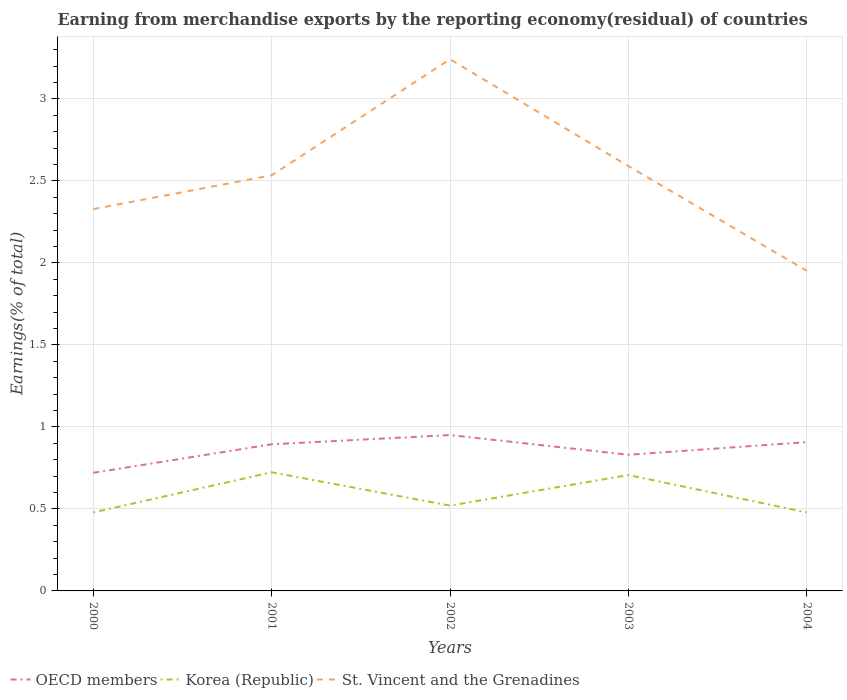How many different coloured lines are there?
Give a very brief answer. 3. Is the number of lines equal to the number of legend labels?
Give a very brief answer. Yes. Across all years, what is the maximum percentage of amount earned from merchandise exports in Korea (Republic)?
Your answer should be compact. 0.48. In which year was the percentage of amount earned from merchandise exports in OECD members maximum?
Your answer should be very brief. 2000. What is the total percentage of amount earned from merchandise exports in OECD members in the graph?
Provide a short and direct response. -0.19. What is the difference between the highest and the second highest percentage of amount earned from merchandise exports in OECD members?
Your answer should be compact. 0.23. Is the percentage of amount earned from merchandise exports in Korea (Republic) strictly greater than the percentage of amount earned from merchandise exports in St. Vincent and the Grenadines over the years?
Your answer should be compact. Yes. How many lines are there?
Provide a succinct answer. 3. Does the graph contain grids?
Provide a short and direct response. Yes. How many legend labels are there?
Ensure brevity in your answer.  3. How are the legend labels stacked?
Your response must be concise. Horizontal. What is the title of the graph?
Your answer should be compact. Earning from merchandise exports by the reporting economy(residual) of countries. What is the label or title of the Y-axis?
Make the answer very short. Earnings(% of total). What is the Earnings(% of total) in OECD members in 2000?
Your response must be concise. 0.72. What is the Earnings(% of total) of Korea (Republic) in 2000?
Your answer should be compact. 0.48. What is the Earnings(% of total) of St. Vincent and the Grenadines in 2000?
Provide a short and direct response. 2.33. What is the Earnings(% of total) in OECD members in 2001?
Offer a very short reply. 0.89. What is the Earnings(% of total) in Korea (Republic) in 2001?
Make the answer very short. 0.72. What is the Earnings(% of total) of St. Vincent and the Grenadines in 2001?
Offer a very short reply. 2.53. What is the Earnings(% of total) in OECD members in 2002?
Offer a terse response. 0.95. What is the Earnings(% of total) in Korea (Republic) in 2002?
Give a very brief answer. 0.52. What is the Earnings(% of total) in St. Vincent and the Grenadines in 2002?
Keep it short and to the point. 3.24. What is the Earnings(% of total) of OECD members in 2003?
Your answer should be compact. 0.83. What is the Earnings(% of total) of Korea (Republic) in 2003?
Give a very brief answer. 0.71. What is the Earnings(% of total) in St. Vincent and the Grenadines in 2003?
Keep it short and to the point. 2.59. What is the Earnings(% of total) of OECD members in 2004?
Provide a short and direct response. 0.91. What is the Earnings(% of total) in Korea (Republic) in 2004?
Your response must be concise. 0.48. What is the Earnings(% of total) of St. Vincent and the Grenadines in 2004?
Offer a very short reply. 1.95. Across all years, what is the maximum Earnings(% of total) of OECD members?
Provide a succinct answer. 0.95. Across all years, what is the maximum Earnings(% of total) of Korea (Republic)?
Ensure brevity in your answer.  0.72. Across all years, what is the maximum Earnings(% of total) in St. Vincent and the Grenadines?
Keep it short and to the point. 3.24. Across all years, what is the minimum Earnings(% of total) in OECD members?
Provide a short and direct response. 0.72. Across all years, what is the minimum Earnings(% of total) of Korea (Republic)?
Your answer should be very brief. 0.48. Across all years, what is the minimum Earnings(% of total) of St. Vincent and the Grenadines?
Your answer should be compact. 1.95. What is the total Earnings(% of total) in OECD members in the graph?
Provide a succinct answer. 4.3. What is the total Earnings(% of total) in Korea (Republic) in the graph?
Offer a terse response. 2.91. What is the total Earnings(% of total) of St. Vincent and the Grenadines in the graph?
Provide a succinct answer. 12.65. What is the difference between the Earnings(% of total) of OECD members in 2000 and that in 2001?
Ensure brevity in your answer.  -0.17. What is the difference between the Earnings(% of total) in Korea (Republic) in 2000 and that in 2001?
Provide a short and direct response. -0.24. What is the difference between the Earnings(% of total) of St. Vincent and the Grenadines in 2000 and that in 2001?
Keep it short and to the point. -0.21. What is the difference between the Earnings(% of total) in OECD members in 2000 and that in 2002?
Your answer should be very brief. -0.23. What is the difference between the Earnings(% of total) of Korea (Republic) in 2000 and that in 2002?
Your answer should be very brief. -0.04. What is the difference between the Earnings(% of total) in St. Vincent and the Grenadines in 2000 and that in 2002?
Your answer should be compact. -0.91. What is the difference between the Earnings(% of total) in OECD members in 2000 and that in 2003?
Ensure brevity in your answer.  -0.11. What is the difference between the Earnings(% of total) of Korea (Republic) in 2000 and that in 2003?
Ensure brevity in your answer.  -0.23. What is the difference between the Earnings(% of total) in St. Vincent and the Grenadines in 2000 and that in 2003?
Provide a succinct answer. -0.26. What is the difference between the Earnings(% of total) of OECD members in 2000 and that in 2004?
Make the answer very short. -0.19. What is the difference between the Earnings(% of total) of Korea (Republic) in 2000 and that in 2004?
Offer a very short reply. -0. What is the difference between the Earnings(% of total) of St. Vincent and the Grenadines in 2000 and that in 2004?
Your response must be concise. 0.38. What is the difference between the Earnings(% of total) of OECD members in 2001 and that in 2002?
Give a very brief answer. -0.06. What is the difference between the Earnings(% of total) in Korea (Republic) in 2001 and that in 2002?
Keep it short and to the point. 0.2. What is the difference between the Earnings(% of total) in St. Vincent and the Grenadines in 2001 and that in 2002?
Your response must be concise. -0.71. What is the difference between the Earnings(% of total) in OECD members in 2001 and that in 2003?
Give a very brief answer. 0.06. What is the difference between the Earnings(% of total) in Korea (Republic) in 2001 and that in 2003?
Your answer should be very brief. 0.02. What is the difference between the Earnings(% of total) of St. Vincent and the Grenadines in 2001 and that in 2003?
Give a very brief answer. -0.06. What is the difference between the Earnings(% of total) of OECD members in 2001 and that in 2004?
Give a very brief answer. -0.01. What is the difference between the Earnings(% of total) of Korea (Republic) in 2001 and that in 2004?
Your answer should be compact. 0.24. What is the difference between the Earnings(% of total) in St. Vincent and the Grenadines in 2001 and that in 2004?
Your response must be concise. 0.58. What is the difference between the Earnings(% of total) of OECD members in 2002 and that in 2003?
Offer a very short reply. 0.12. What is the difference between the Earnings(% of total) of Korea (Republic) in 2002 and that in 2003?
Your answer should be very brief. -0.19. What is the difference between the Earnings(% of total) of St. Vincent and the Grenadines in 2002 and that in 2003?
Offer a terse response. 0.65. What is the difference between the Earnings(% of total) of OECD members in 2002 and that in 2004?
Your response must be concise. 0.04. What is the difference between the Earnings(% of total) in Korea (Republic) in 2002 and that in 2004?
Offer a very short reply. 0.04. What is the difference between the Earnings(% of total) of St. Vincent and the Grenadines in 2002 and that in 2004?
Give a very brief answer. 1.29. What is the difference between the Earnings(% of total) of OECD members in 2003 and that in 2004?
Your answer should be very brief. -0.08. What is the difference between the Earnings(% of total) of Korea (Republic) in 2003 and that in 2004?
Provide a short and direct response. 0.23. What is the difference between the Earnings(% of total) in St. Vincent and the Grenadines in 2003 and that in 2004?
Ensure brevity in your answer.  0.64. What is the difference between the Earnings(% of total) of OECD members in 2000 and the Earnings(% of total) of Korea (Republic) in 2001?
Your answer should be compact. -0. What is the difference between the Earnings(% of total) in OECD members in 2000 and the Earnings(% of total) in St. Vincent and the Grenadines in 2001?
Keep it short and to the point. -1.81. What is the difference between the Earnings(% of total) in Korea (Republic) in 2000 and the Earnings(% of total) in St. Vincent and the Grenadines in 2001?
Offer a very short reply. -2.06. What is the difference between the Earnings(% of total) in OECD members in 2000 and the Earnings(% of total) in Korea (Republic) in 2002?
Keep it short and to the point. 0.2. What is the difference between the Earnings(% of total) in OECD members in 2000 and the Earnings(% of total) in St. Vincent and the Grenadines in 2002?
Keep it short and to the point. -2.52. What is the difference between the Earnings(% of total) in Korea (Republic) in 2000 and the Earnings(% of total) in St. Vincent and the Grenadines in 2002?
Provide a short and direct response. -2.76. What is the difference between the Earnings(% of total) of OECD members in 2000 and the Earnings(% of total) of Korea (Republic) in 2003?
Offer a terse response. 0.01. What is the difference between the Earnings(% of total) in OECD members in 2000 and the Earnings(% of total) in St. Vincent and the Grenadines in 2003?
Keep it short and to the point. -1.87. What is the difference between the Earnings(% of total) in Korea (Republic) in 2000 and the Earnings(% of total) in St. Vincent and the Grenadines in 2003?
Make the answer very short. -2.11. What is the difference between the Earnings(% of total) in OECD members in 2000 and the Earnings(% of total) in Korea (Republic) in 2004?
Ensure brevity in your answer.  0.24. What is the difference between the Earnings(% of total) in OECD members in 2000 and the Earnings(% of total) in St. Vincent and the Grenadines in 2004?
Keep it short and to the point. -1.23. What is the difference between the Earnings(% of total) in Korea (Republic) in 2000 and the Earnings(% of total) in St. Vincent and the Grenadines in 2004?
Offer a very short reply. -1.47. What is the difference between the Earnings(% of total) in OECD members in 2001 and the Earnings(% of total) in Korea (Republic) in 2002?
Offer a very short reply. 0.37. What is the difference between the Earnings(% of total) in OECD members in 2001 and the Earnings(% of total) in St. Vincent and the Grenadines in 2002?
Offer a very short reply. -2.35. What is the difference between the Earnings(% of total) in Korea (Republic) in 2001 and the Earnings(% of total) in St. Vincent and the Grenadines in 2002?
Your answer should be compact. -2.52. What is the difference between the Earnings(% of total) in OECD members in 2001 and the Earnings(% of total) in Korea (Republic) in 2003?
Give a very brief answer. 0.19. What is the difference between the Earnings(% of total) in OECD members in 2001 and the Earnings(% of total) in St. Vincent and the Grenadines in 2003?
Offer a terse response. -1.7. What is the difference between the Earnings(% of total) in Korea (Republic) in 2001 and the Earnings(% of total) in St. Vincent and the Grenadines in 2003?
Offer a terse response. -1.87. What is the difference between the Earnings(% of total) of OECD members in 2001 and the Earnings(% of total) of Korea (Republic) in 2004?
Offer a terse response. 0.42. What is the difference between the Earnings(% of total) of OECD members in 2001 and the Earnings(% of total) of St. Vincent and the Grenadines in 2004?
Keep it short and to the point. -1.06. What is the difference between the Earnings(% of total) in Korea (Republic) in 2001 and the Earnings(% of total) in St. Vincent and the Grenadines in 2004?
Your answer should be compact. -1.23. What is the difference between the Earnings(% of total) of OECD members in 2002 and the Earnings(% of total) of Korea (Republic) in 2003?
Your response must be concise. 0.24. What is the difference between the Earnings(% of total) in OECD members in 2002 and the Earnings(% of total) in St. Vincent and the Grenadines in 2003?
Provide a succinct answer. -1.64. What is the difference between the Earnings(% of total) of Korea (Republic) in 2002 and the Earnings(% of total) of St. Vincent and the Grenadines in 2003?
Your answer should be very brief. -2.07. What is the difference between the Earnings(% of total) of OECD members in 2002 and the Earnings(% of total) of Korea (Republic) in 2004?
Ensure brevity in your answer.  0.47. What is the difference between the Earnings(% of total) of OECD members in 2002 and the Earnings(% of total) of St. Vincent and the Grenadines in 2004?
Keep it short and to the point. -1. What is the difference between the Earnings(% of total) of Korea (Republic) in 2002 and the Earnings(% of total) of St. Vincent and the Grenadines in 2004?
Ensure brevity in your answer.  -1.43. What is the difference between the Earnings(% of total) of OECD members in 2003 and the Earnings(% of total) of Korea (Republic) in 2004?
Your response must be concise. 0.35. What is the difference between the Earnings(% of total) in OECD members in 2003 and the Earnings(% of total) in St. Vincent and the Grenadines in 2004?
Your answer should be compact. -1.12. What is the difference between the Earnings(% of total) of Korea (Republic) in 2003 and the Earnings(% of total) of St. Vincent and the Grenadines in 2004?
Provide a succinct answer. -1.25. What is the average Earnings(% of total) in OECD members per year?
Offer a terse response. 0.86. What is the average Earnings(% of total) in Korea (Republic) per year?
Give a very brief answer. 0.58. What is the average Earnings(% of total) in St. Vincent and the Grenadines per year?
Ensure brevity in your answer.  2.53. In the year 2000, what is the difference between the Earnings(% of total) of OECD members and Earnings(% of total) of Korea (Republic)?
Offer a very short reply. 0.24. In the year 2000, what is the difference between the Earnings(% of total) of OECD members and Earnings(% of total) of St. Vincent and the Grenadines?
Your answer should be compact. -1.61. In the year 2000, what is the difference between the Earnings(% of total) of Korea (Republic) and Earnings(% of total) of St. Vincent and the Grenadines?
Ensure brevity in your answer.  -1.85. In the year 2001, what is the difference between the Earnings(% of total) of OECD members and Earnings(% of total) of Korea (Republic)?
Make the answer very short. 0.17. In the year 2001, what is the difference between the Earnings(% of total) of OECD members and Earnings(% of total) of St. Vincent and the Grenadines?
Your answer should be very brief. -1.64. In the year 2001, what is the difference between the Earnings(% of total) of Korea (Republic) and Earnings(% of total) of St. Vincent and the Grenadines?
Your answer should be compact. -1.81. In the year 2002, what is the difference between the Earnings(% of total) in OECD members and Earnings(% of total) in Korea (Republic)?
Offer a very short reply. 0.43. In the year 2002, what is the difference between the Earnings(% of total) of OECD members and Earnings(% of total) of St. Vincent and the Grenadines?
Your response must be concise. -2.29. In the year 2002, what is the difference between the Earnings(% of total) of Korea (Republic) and Earnings(% of total) of St. Vincent and the Grenadines?
Your response must be concise. -2.72. In the year 2003, what is the difference between the Earnings(% of total) of OECD members and Earnings(% of total) of Korea (Republic)?
Keep it short and to the point. 0.12. In the year 2003, what is the difference between the Earnings(% of total) in OECD members and Earnings(% of total) in St. Vincent and the Grenadines?
Your response must be concise. -1.76. In the year 2003, what is the difference between the Earnings(% of total) in Korea (Republic) and Earnings(% of total) in St. Vincent and the Grenadines?
Your answer should be very brief. -1.88. In the year 2004, what is the difference between the Earnings(% of total) in OECD members and Earnings(% of total) in Korea (Republic)?
Ensure brevity in your answer.  0.43. In the year 2004, what is the difference between the Earnings(% of total) of OECD members and Earnings(% of total) of St. Vincent and the Grenadines?
Keep it short and to the point. -1.04. In the year 2004, what is the difference between the Earnings(% of total) of Korea (Republic) and Earnings(% of total) of St. Vincent and the Grenadines?
Keep it short and to the point. -1.47. What is the ratio of the Earnings(% of total) of OECD members in 2000 to that in 2001?
Offer a terse response. 0.81. What is the ratio of the Earnings(% of total) in Korea (Republic) in 2000 to that in 2001?
Offer a terse response. 0.66. What is the ratio of the Earnings(% of total) of St. Vincent and the Grenadines in 2000 to that in 2001?
Keep it short and to the point. 0.92. What is the ratio of the Earnings(% of total) of OECD members in 2000 to that in 2002?
Offer a very short reply. 0.76. What is the ratio of the Earnings(% of total) in Korea (Republic) in 2000 to that in 2002?
Give a very brief answer. 0.92. What is the ratio of the Earnings(% of total) of St. Vincent and the Grenadines in 2000 to that in 2002?
Your response must be concise. 0.72. What is the ratio of the Earnings(% of total) in OECD members in 2000 to that in 2003?
Offer a very short reply. 0.87. What is the ratio of the Earnings(% of total) in Korea (Republic) in 2000 to that in 2003?
Offer a terse response. 0.68. What is the ratio of the Earnings(% of total) in St. Vincent and the Grenadines in 2000 to that in 2003?
Your response must be concise. 0.9. What is the ratio of the Earnings(% of total) in OECD members in 2000 to that in 2004?
Provide a short and direct response. 0.79. What is the ratio of the Earnings(% of total) in St. Vincent and the Grenadines in 2000 to that in 2004?
Give a very brief answer. 1.19. What is the ratio of the Earnings(% of total) of OECD members in 2001 to that in 2002?
Your response must be concise. 0.94. What is the ratio of the Earnings(% of total) in Korea (Republic) in 2001 to that in 2002?
Your response must be concise. 1.39. What is the ratio of the Earnings(% of total) in St. Vincent and the Grenadines in 2001 to that in 2002?
Your response must be concise. 0.78. What is the ratio of the Earnings(% of total) in Korea (Republic) in 2001 to that in 2003?
Keep it short and to the point. 1.02. What is the ratio of the Earnings(% of total) of St. Vincent and the Grenadines in 2001 to that in 2003?
Give a very brief answer. 0.98. What is the ratio of the Earnings(% of total) in OECD members in 2001 to that in 2004?
Your answer should be very brief. 0.99. What is the ratio of the Earnings(% of total) in Korea (Republic) in 2001 to that in 2004?
Give a very brief answer. 1.51. What is the ratio of the Earnings(% of total) in St. Vincent and the Grenadines in 2001 to that in 2004?
Offer a very short reply. 1.3. What is the ratio of the Earnings(% of total) of OECD members in 2002 to that in 2003?
Your answer should be compact. 1.14. What is the ratio of the Earnings(% of total) of Korea (Republic) in 2002 to that in 2003?
Ensure brevity in your answer.  0.74. What is the ratio of the Earnings(% of total) in St. Vincent and the Grenadines in 2002 to that in 2003?
Give a very brief answer. 1.25. What is the ratio of the Earnings(% of total) in OECD members in 2002 to that in 2004?
Keep it short and to the point. 1.05. What is the ratio of the Earnings(% of total) of Korea (Republic) in 2002 to that in 2004?
Your answer should be compact. 1.09. What is the ratio of the Earnings(% of total) of St. Vincent and the Grenadines in 2002 to that in 2004?
Keep it short and to the point. 1.66. What is the ratio of the Earnings(% of total) of OECD members in 2003 to that in 2004?
Offer a terse response. 0.91. What is the ratio of the Earnings(% of total) in Korea (Republic) in 2003 to that in 2004?
Give a very brief answer. 1.48. What is the ratio of the Earnings(% of total) in St. Vincent and the Grenadines in 2003 to that in 2004?
Make the answer very short. 1.33. What is the difference between the highest and the second highest Earnings(% of total) of OECD members?
Offer a very short reply. 0.04. What is the difference between the highest and the second highest Earnings(% of total) of Korea (Republic)?
Your response must be concise. 0.02. What is the difference between the highest and the second highest Earnings(% of total) in St. Vincent and the Grenadines?
Keep it short and to the point. 0.65. What is the difference between the highest and the lowest Earnings(% of total) in OECD members?
Offer a very short reply. 0.23. What is the difference between the highest and the lowest Earnings(% of total) in Korea (Republic)?
Provide a succinct answer. 0.24. What is the difference between the highest and the lowest Earnings(% of total) in St. Vincent and the Grenadines?
Offer a very short reply. 1.29. 